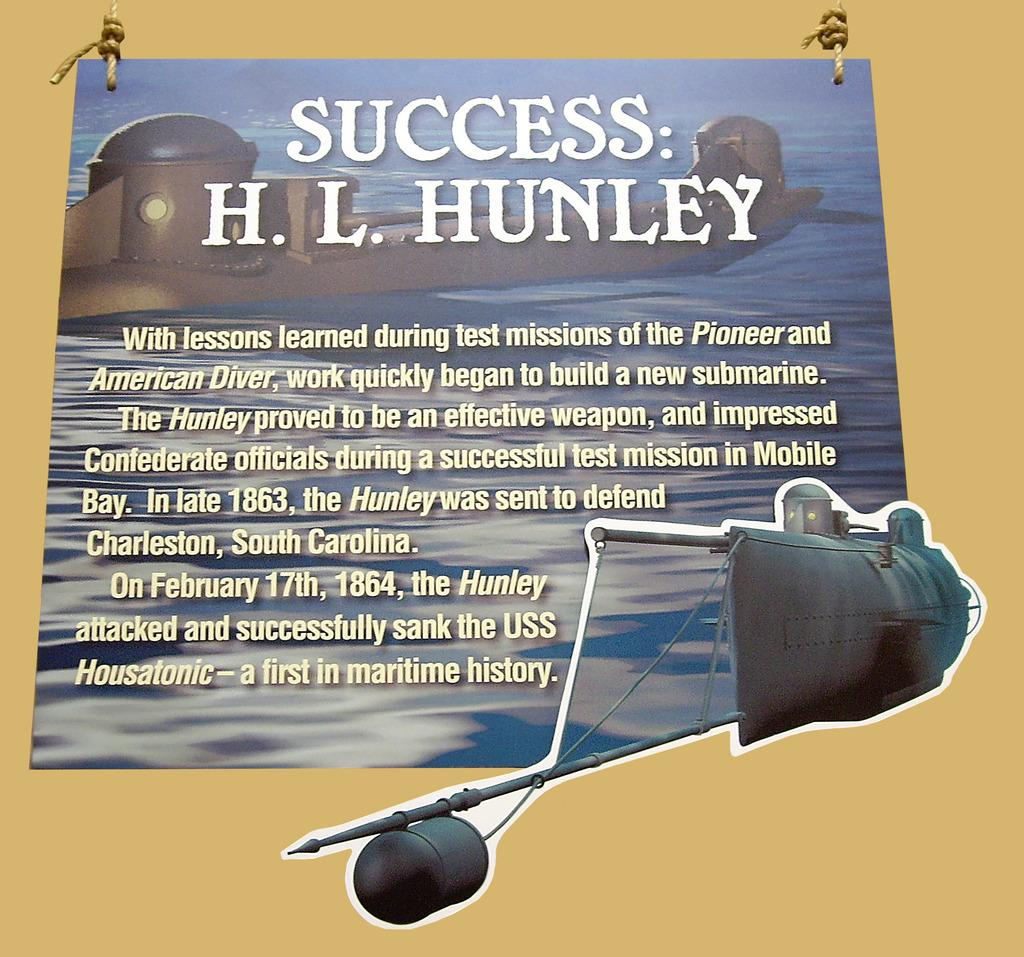<image>
Offer a succinct explanation of the picture presented. A poster provides information on the H.L. Hunley submarine. 